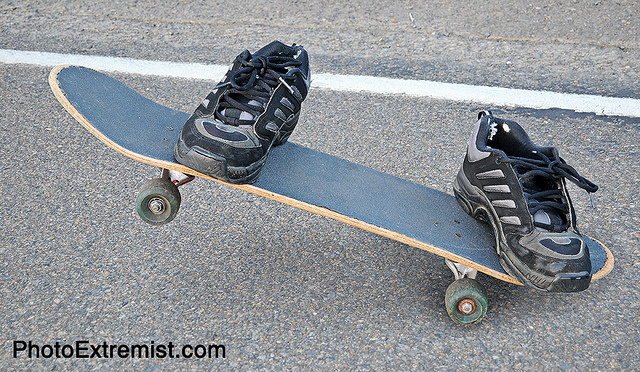Describe the objects in this image and their specific colors. I can see a skateboard in gray and darkgray tones in this image. 